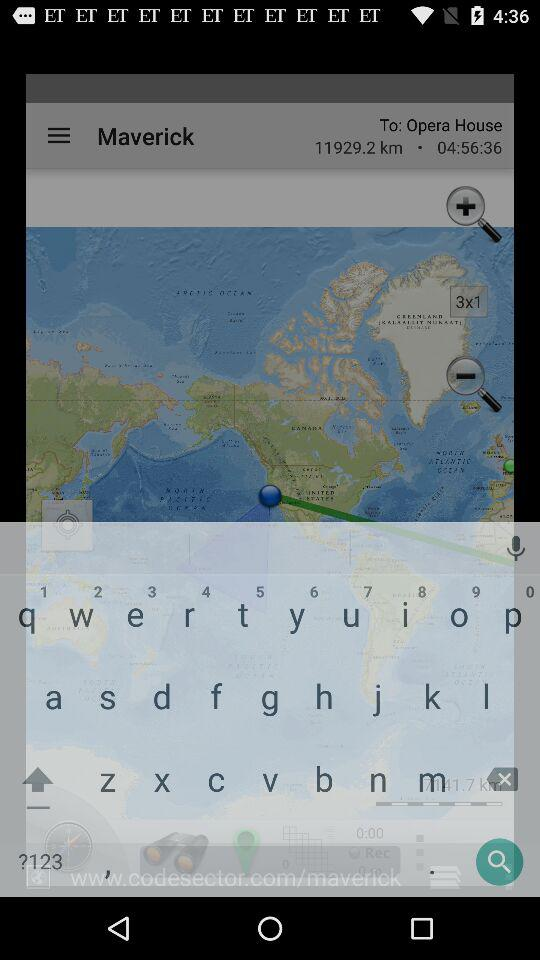In which city is the user located?
When the provided information is insufficient, respond with <no answer>. <no answer> 